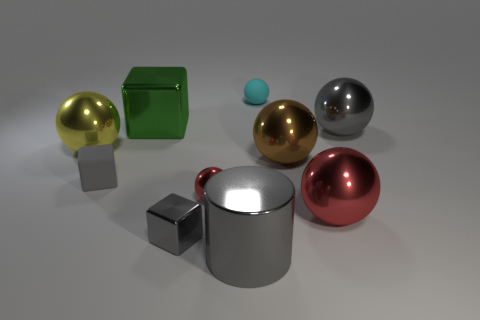What number of other objects are the same shape as the green metallic thing?
Give a very brief answer. 2. There is a rubber object in front of the green metallic cube; what shape is it?
Keep it short and to the point. Cube. Do the cyan sphere and the large ball that is to the left of the big gray shiny cylinder have the same material?
Provide a short and direct response. No. Is the shape of the cyan matte object the same as the large red thing?
Offer a very short reply. Yes. There is a gray object that is the same shape as the brown metal object; what is its material?
Keep it short and to the point. Metal. There is a cube that is in front of the big yellow metal ball and to the right of the gray matte thing; what color is it?
Provide a short and direct response. Gray. The tiny metallic sphere is what color?
Make the answer very short. Red. What is the material of the big sphere that is the same color as the small metallic ball?
Provide a short and direct response. Metal. Are there any other brown objects of the same shape as the brown object?
Ensure brevity in your answer.  No. What is the size of the gray metallic thing behind the big yellow shiny ball?
Keep it short and to the point. Large. 